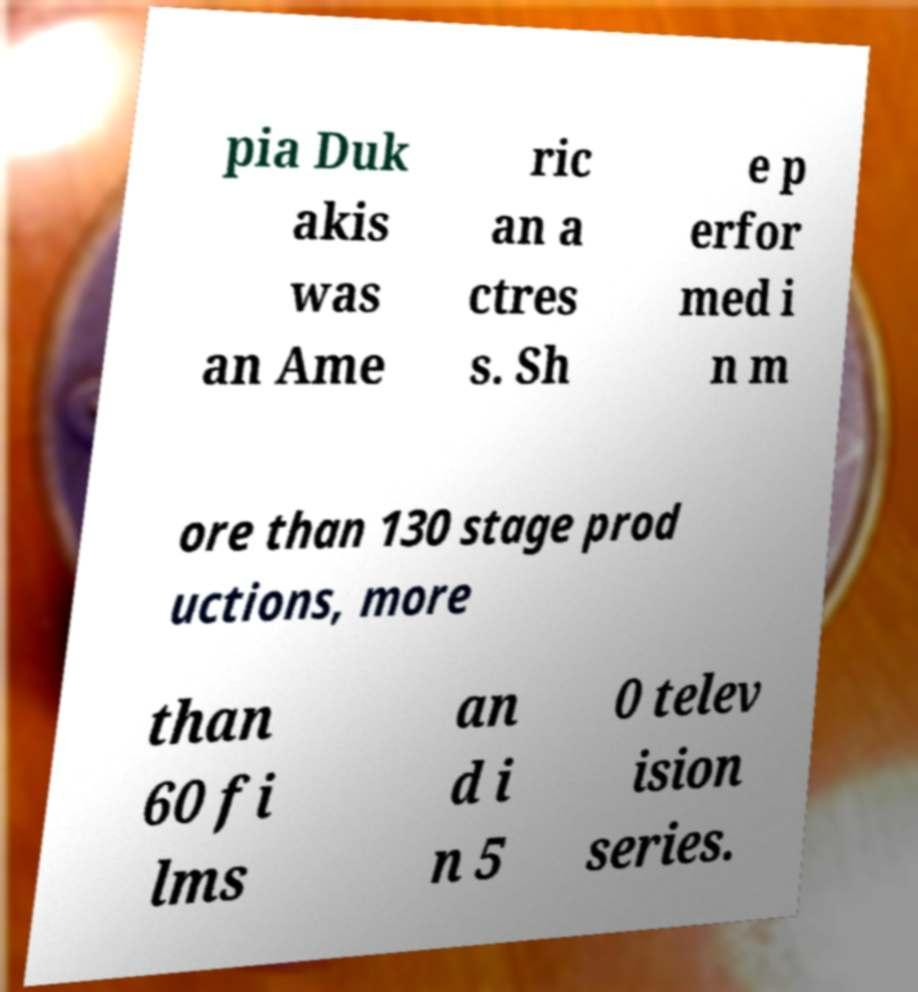Can you accurately transcribe the text from the provided image for me? pia Duk akis was an Ame ric an a ctres s. Sh e p erfor med i n m ore than 130 stage prod uctions, more than 60 fi lms an d i n 5 0 telev ision series. 